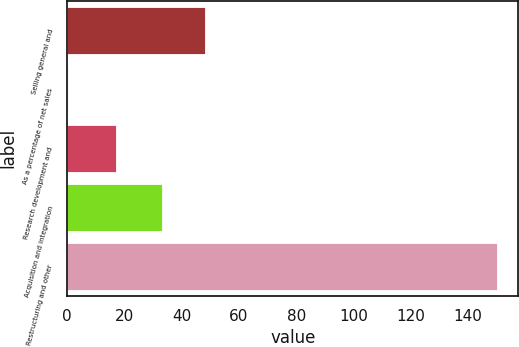Convert chart to OTSL. <chart><loc_0><loc_0><loc_500><loc_500><bar_chart><fcel>Selling general and<fcel>As a percentage of net sales<fcel>Research development and<fcel>Acquisition and integration<fcel>Restructuring and other<nl><fcel>47.97<fcel>0.3<fcel>17<fcel>33<fcel>150<nl></chart> 